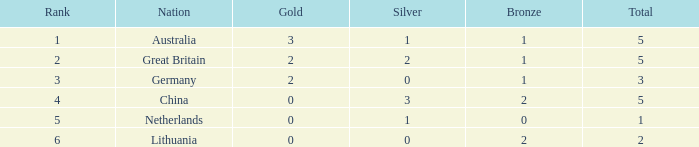What is the average for silver when bronze is less than 1, and gold is more than 0? None. 